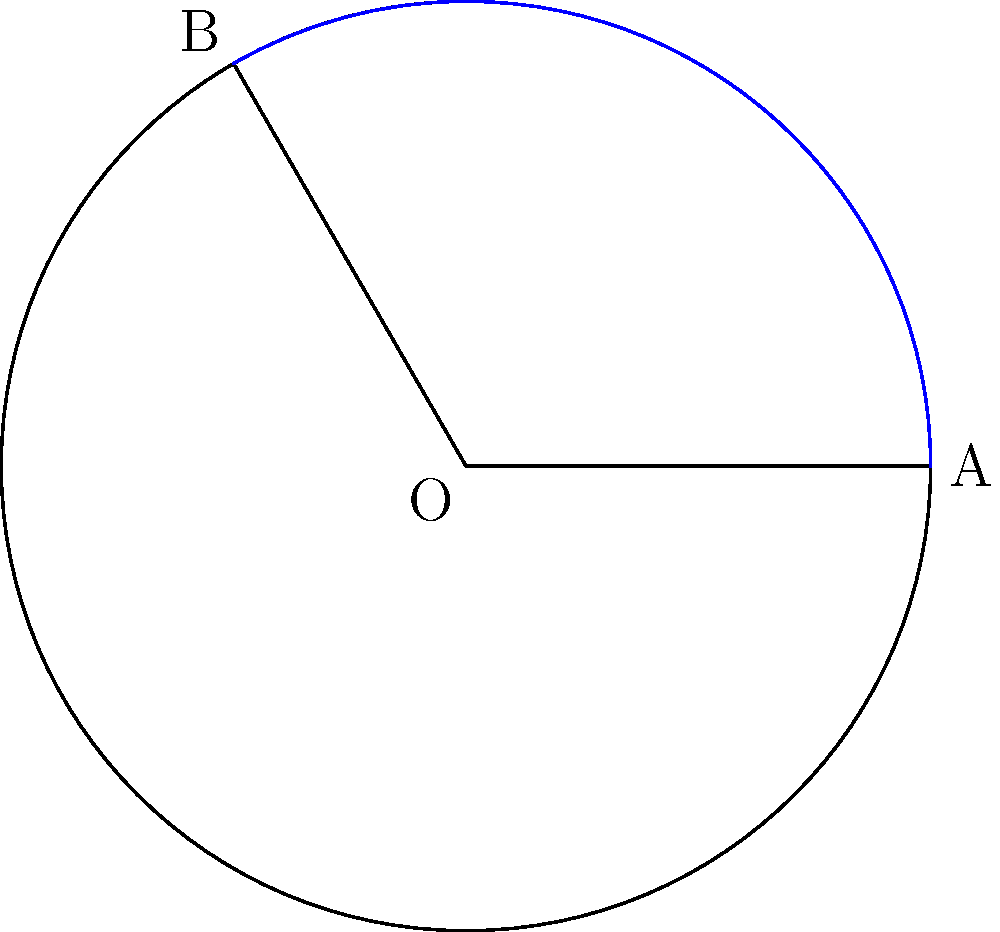During a jam session, you notice the vibration pattern of your guitar string forms a circular segment. If the radius of the circle is 12 cm (like the length of a standard guitar fret) and the central angle is $\frac{2\pi}{3}$ radians (similar to a common chord progression in Jewish music), what is the area of this circular segment in square centimeters? To find the area of a circular segment, we need to follow these steps:

1) The area of a circular segment is the difference between the area of a sector and the area of a triangle formed by the two radii.

2) Area of sector:
   $A_{sector} = \frac{1}{2}r^2\theta$
   Where $r$ is the radius and $\theta$ is the central angle in radians.
   $A_{sector} = \frac{1}{2} \cdot 12^2 \cdot \frac{2\pi}{3} = 48\pi$ cm²

3) Area of triangle:
   $A_{triangle} = \frac{1}{2}r^2\sin\theta$
   $A_{triangle} = \frac{1}{2} \cdot 12^2 \cdot \sin(\frac{2\pi}{3}) = 62.35$ cm²

4) Area of segment:
   $A_{segment} = A_{sector} - A_{triangle}$
   $A_{segment} = 48\pi - 62.35 = 88.58$ cm²

Therefore, the area of the circular segment is approximately 88.58 cm².
Answer: $88.58$ cm² 